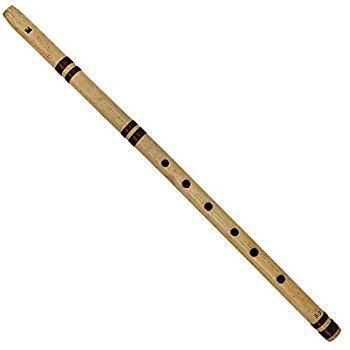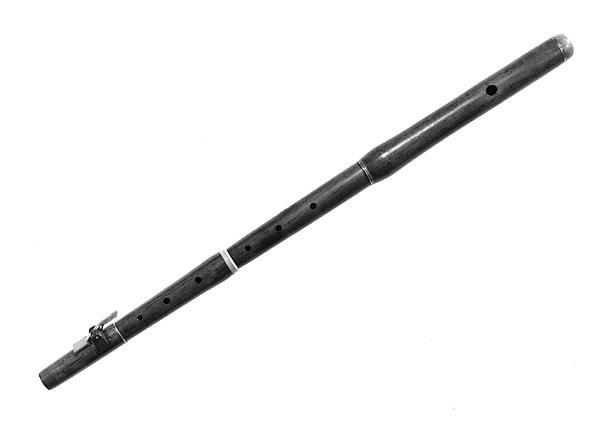The first image is the image on the left, the second image is the image on the right. Analyze the images presented: Is the assertion "There are at least four recorders." valid? Answer yes or no. No. The first image is the image on the left, the second image is the image on the right. Evaluate the accuracy of this statement regarding the images: "One image shows at least three flute items fanned out, with ends together at one end.". Is it true? Answer yes or no. No. 